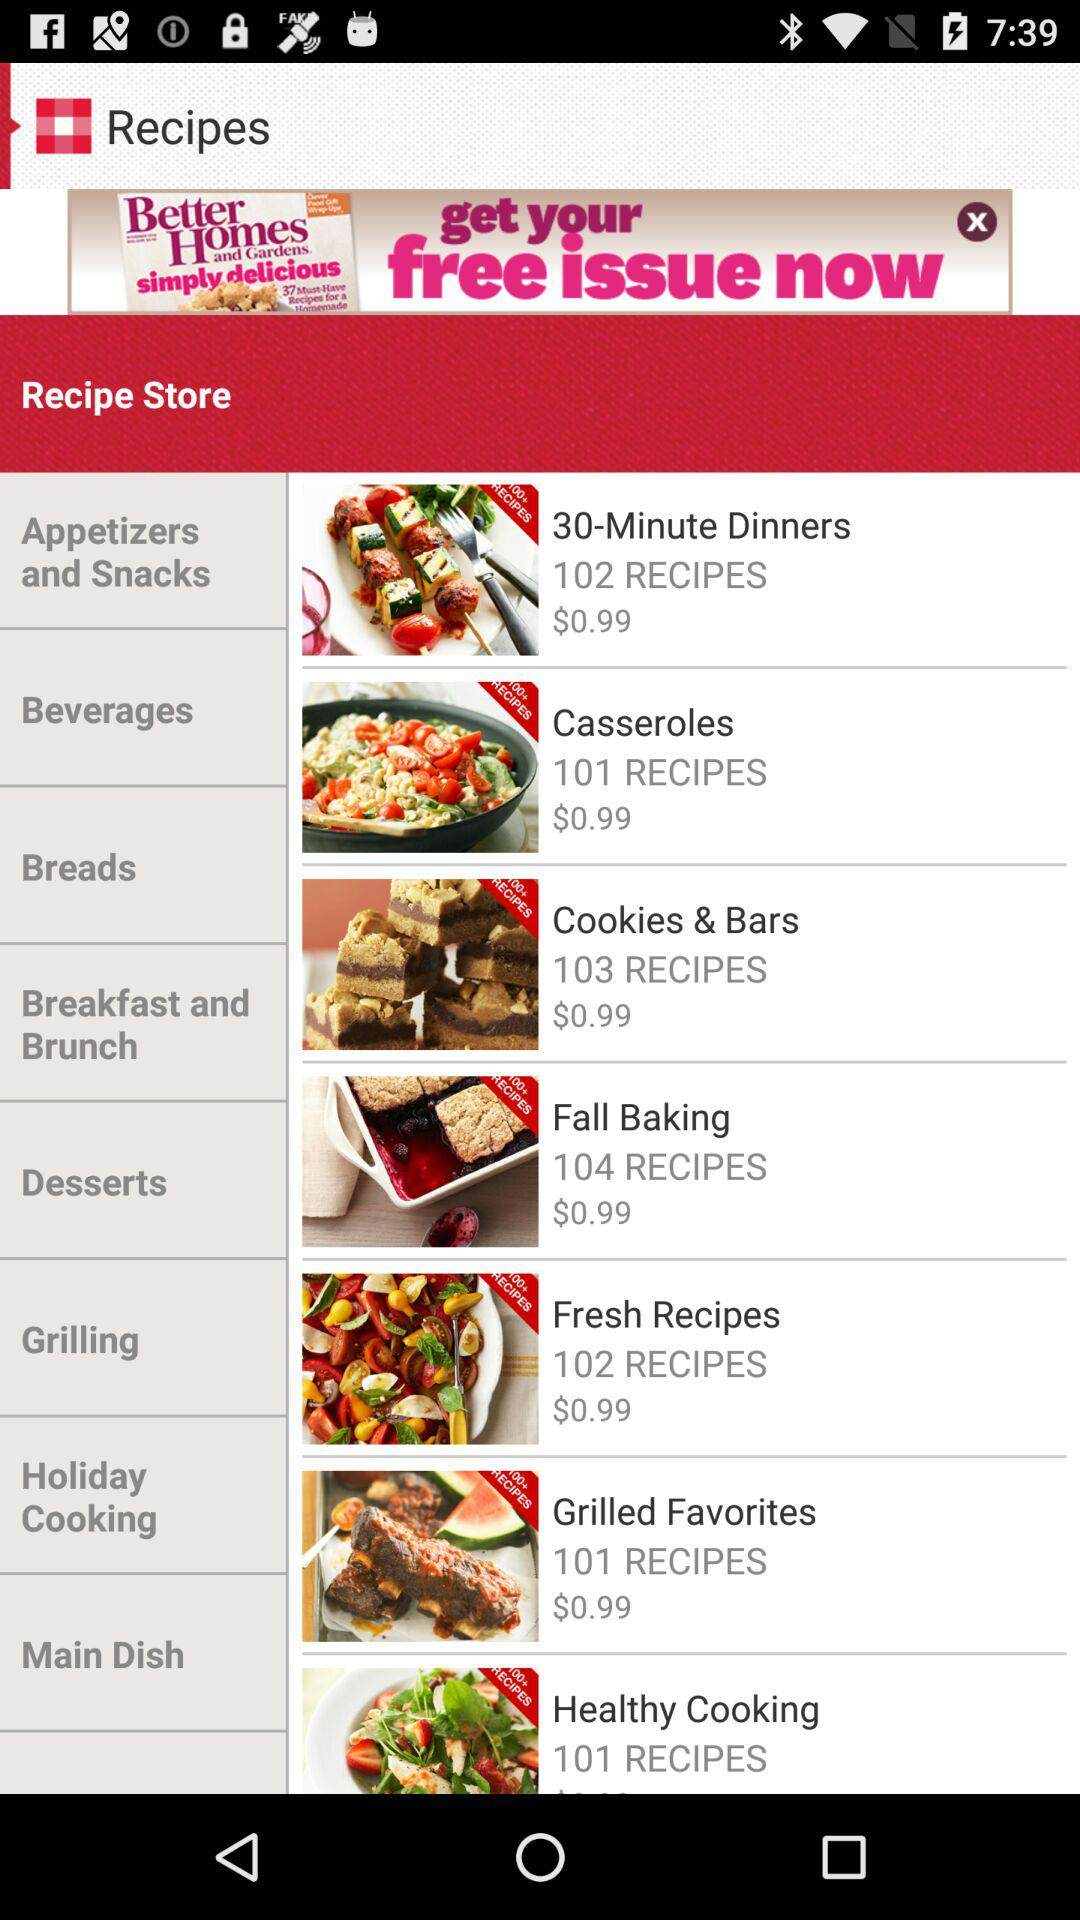What is the price of "Fresh Recipes"? The price of "Fresh Recipes" is $0.99. 